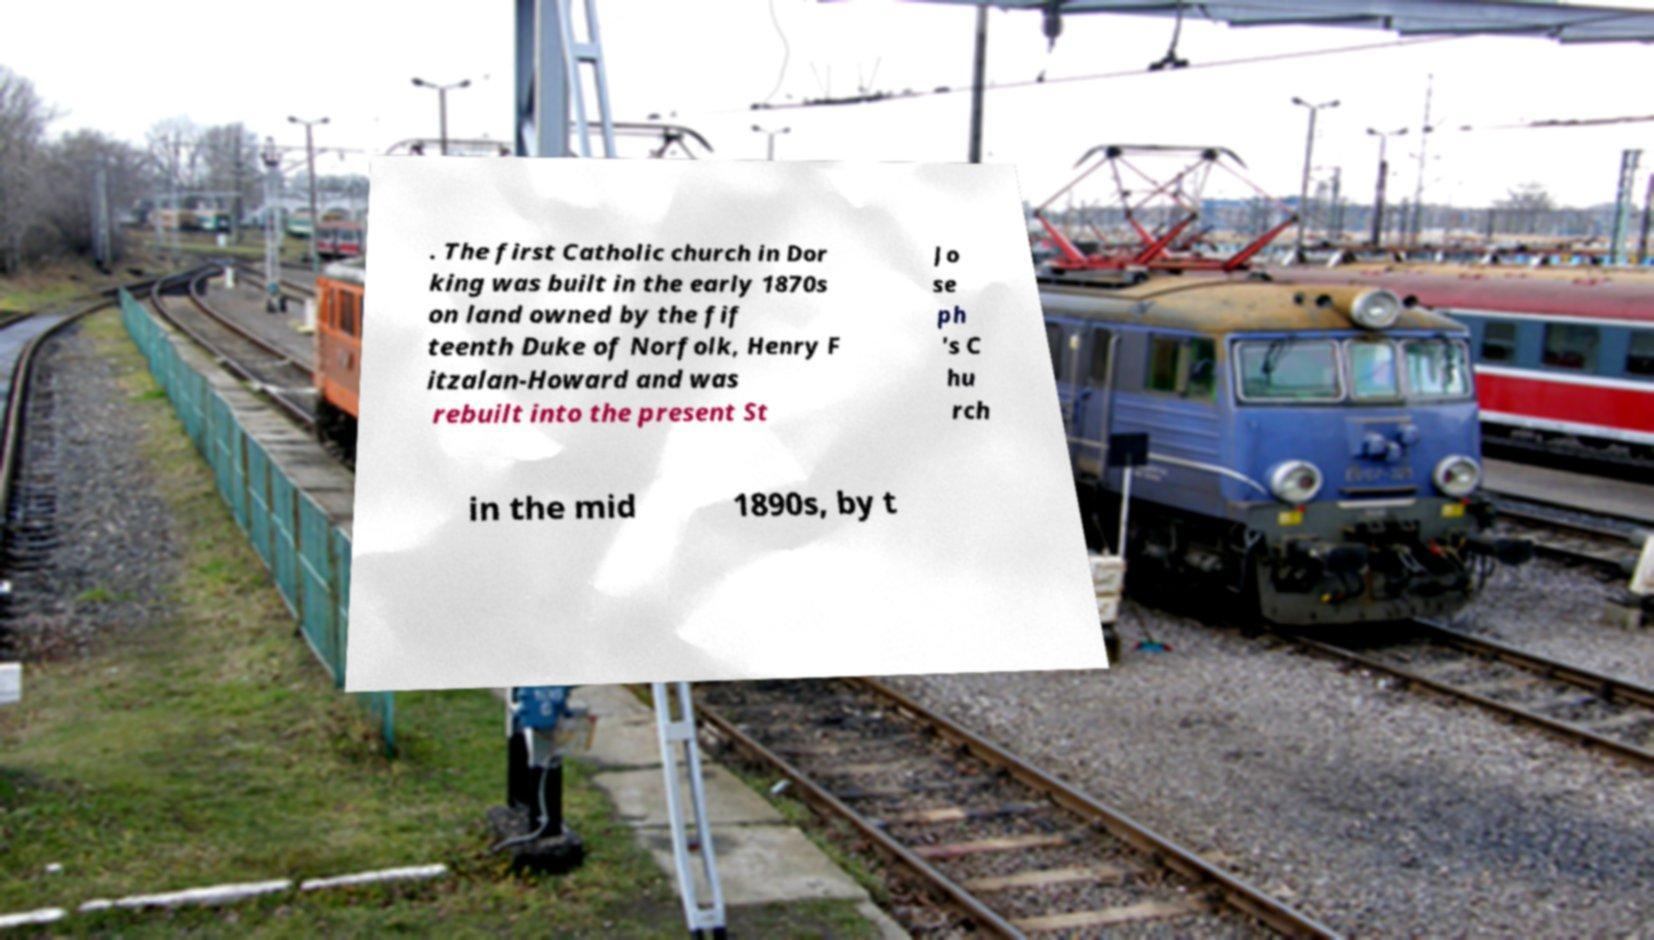Could you assist in decoding the text presented in this image and type it out clearly? . The first Catholic church in Dor king was built in the early 1870s on land owned by the fif teenth Duke of Norfolk, Henry F itzalan-Howard and was rebuilt into the present St Jo se ph 's C hu rch in the mid 1890s, by t 